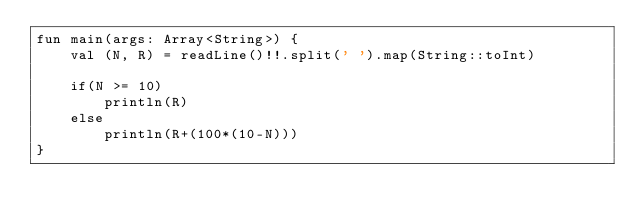<code> <loc_0><loc_0><loc_500><loc_500><_Kotlin_>fun main(args: Array<String>) {
    val (N, R) = readLine()!!.split(' ').map(String::toInt)

    if(N >= 10)
        println(R)
    else
        println(R+(100*(10-N)))
}</code> 